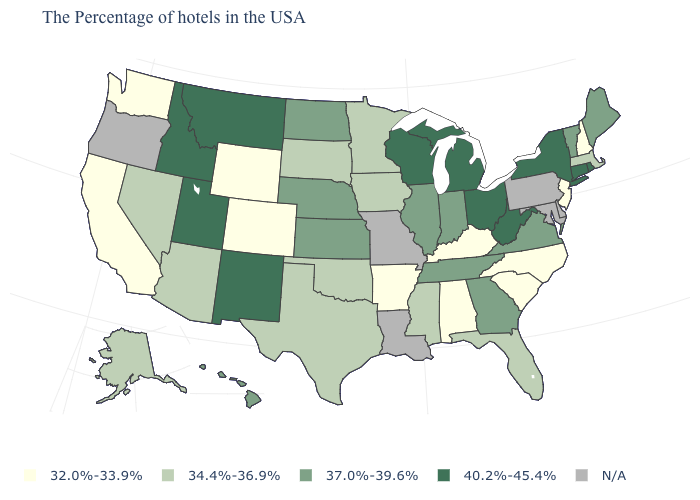What is the lowest value in the USA?
Write a very short answer. 32.0%-33.9%. What is the value of New York?
Write a very short answer. 40.2%-45.4%. What is the value of Indiana?
Give a very brief answer. 37.0%-39.6%. What is the value of Vermont?
Short answer required. 37.0%-39.6%. What is the value of Indiana?
Short answer required. 37.0%-39.6%. Which states have the highest value in the USA?
Quick response, please. Rhode Island, Connecticut, New York, West Virginia, Ohio, Michigan, Wisconsin, New Mexico, Utah, Montana, Idaho. Name the states that have a value in the range 34.4%-36.9%?
Be succinct. Massachusetts, Florida, Mississippi, Minnesota, Iowa, Oklahoma, Texas, South Dakota, Arizona, Nevada, Alaska. Does Ohio have the highest value in the USA?
Be succinct. Yes. Among the states that border Arkansas , which have the highest value?
Quick response, please. Tennessee. Which states have the highest value in the USA?
Keep it brief. Rhode Island, Connecticut, New York, West Virginia, Ohio, Michigan, Wisconsin, New Mexico, Utah, Montana, Idaho. What is the lowest value in states that border Michigan?
Quick response, please. 37.0%-39.6%. Which states have the lowest value in the Northeast?
Give a very brief answer. New Hampshire, New Jersey. What is the lowest value in states that border Virginia?
Write a very short answer. 32.0%-33.9%. 